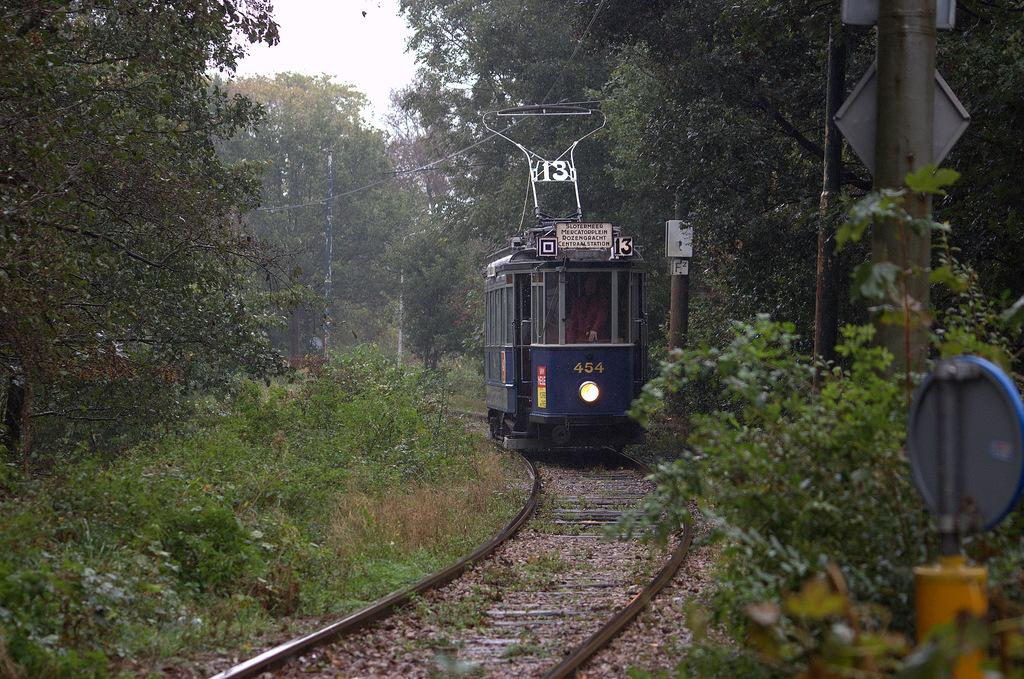What is the main subject of the image? The main subject of the image is a train. What is the train doing in the image? The train is running on a railway track. What type of vegetation can be seen in the image? There are trees in the image. What is the ground covered with in the image? There is grass on the ground in the image. What structures are present in the image? There are poles in the image. What historical event is being celebrated in the image? There is no indication of a historical event or celebration in the image; it simply shows a train running on a railway track. What type of flesh can be seen in the image? There is no flesh visible in the image; it features a train, trees, grass, and poles. 